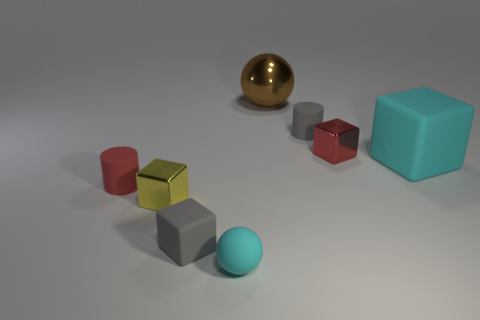What number of things are either tiny yellow metallic objects or tiny purple metal objects?
Your answer should be very brief. 1. There is a cyan matte object that is behind the tiny matte cylinder on the left side of the rubber block that is in front of the tiny red cylinder; what is its shape?
Give a very brief answer. Cube. Are the tiny red object right of the small cyan ball and the cyan object to the right of the large metallic sphere made of the same material?
Ensure brevity in your answer.  No. There is a small red thing that is the same shape as the yellow object; what is it made of?
Your answer should be compact. Metal. There is a small rubber object right of the large brown metal ball; does it have the same shape as the large object that is left of the red block?
Offer a very short reply. No. Are there fewer big spheres that are in front of the small gray matte block than small gray rubber cylinders behind the cyan cube?
Make the answer very short. Yes. How many other things are the same shape as the brown shiny object?
Offer a terse response. 1. There is a yellow thing that is the same material as the big brown sphere; what is its shape?
Keep it short and to the point. Cube. The small rubber thing that is left of the small cyan matte object and right of the red matte thing is what color?
Ensure brevity in your answer.  Gray. Is the material of the tiny red thing left of the small gray rubber block the same as the large brown ball?
Ensure brevity in your answer.  No. 